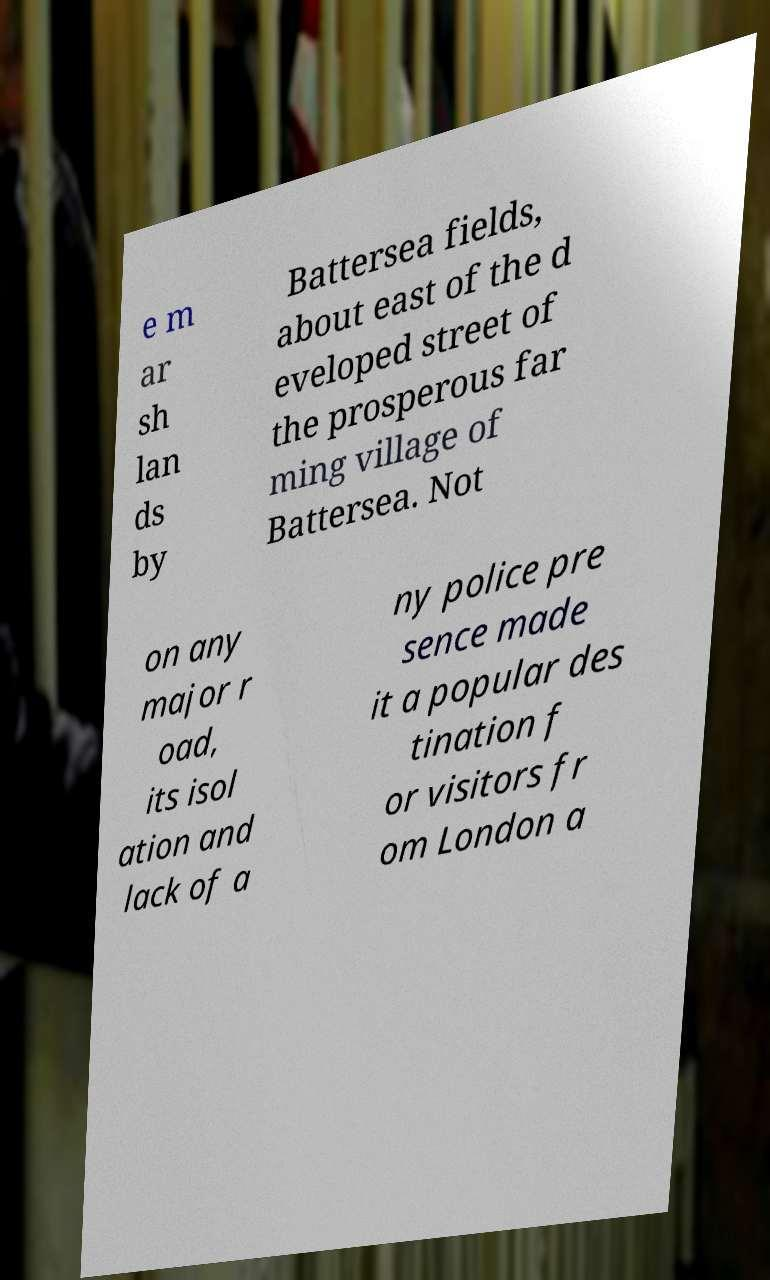There's text embedded in this image that I need extracted. Can you transcribe it verbatim? e m ar sh lan ds by Battersea fields, about east of the d eveloped street of the prosperous far ming village of Battersea. Not on any major r oad, its isol ation and lack of a ny police pre sence made it a popular des tination f or visitors fr om London a 